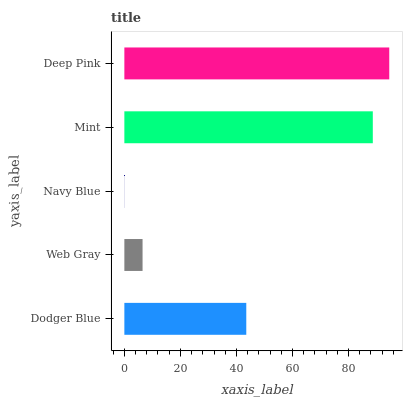Is Navy Blue the minimum?
Answer yes or no. Yes. Is Deep Pink the maximum?
Answer yes or no. Yes. Is Web Gray the minimum?
Answer yes or no. No. Is Web Gray the maximum?
Answer yes or no. No. Is Dodger Blue greater than Web Gray?
Answer yes or no. Yes. Is Web Gray less than Dodger Blue?
Answer yes or no. Yes. Is Web Gray greater than Dodger Blue?
Answer yes or no. No. Is Dodger Blue less than Web Gray?
Answer yes or no. No. Is Dodger Blue the high median?
Answer yes or no. Yes. Is Dodger Blue the low median?
Answer yes or no. Yes. Is Deep Pink the high median?
Answer yes or no. No. Is Web Gray the low median?
Answer yes or no. No. 